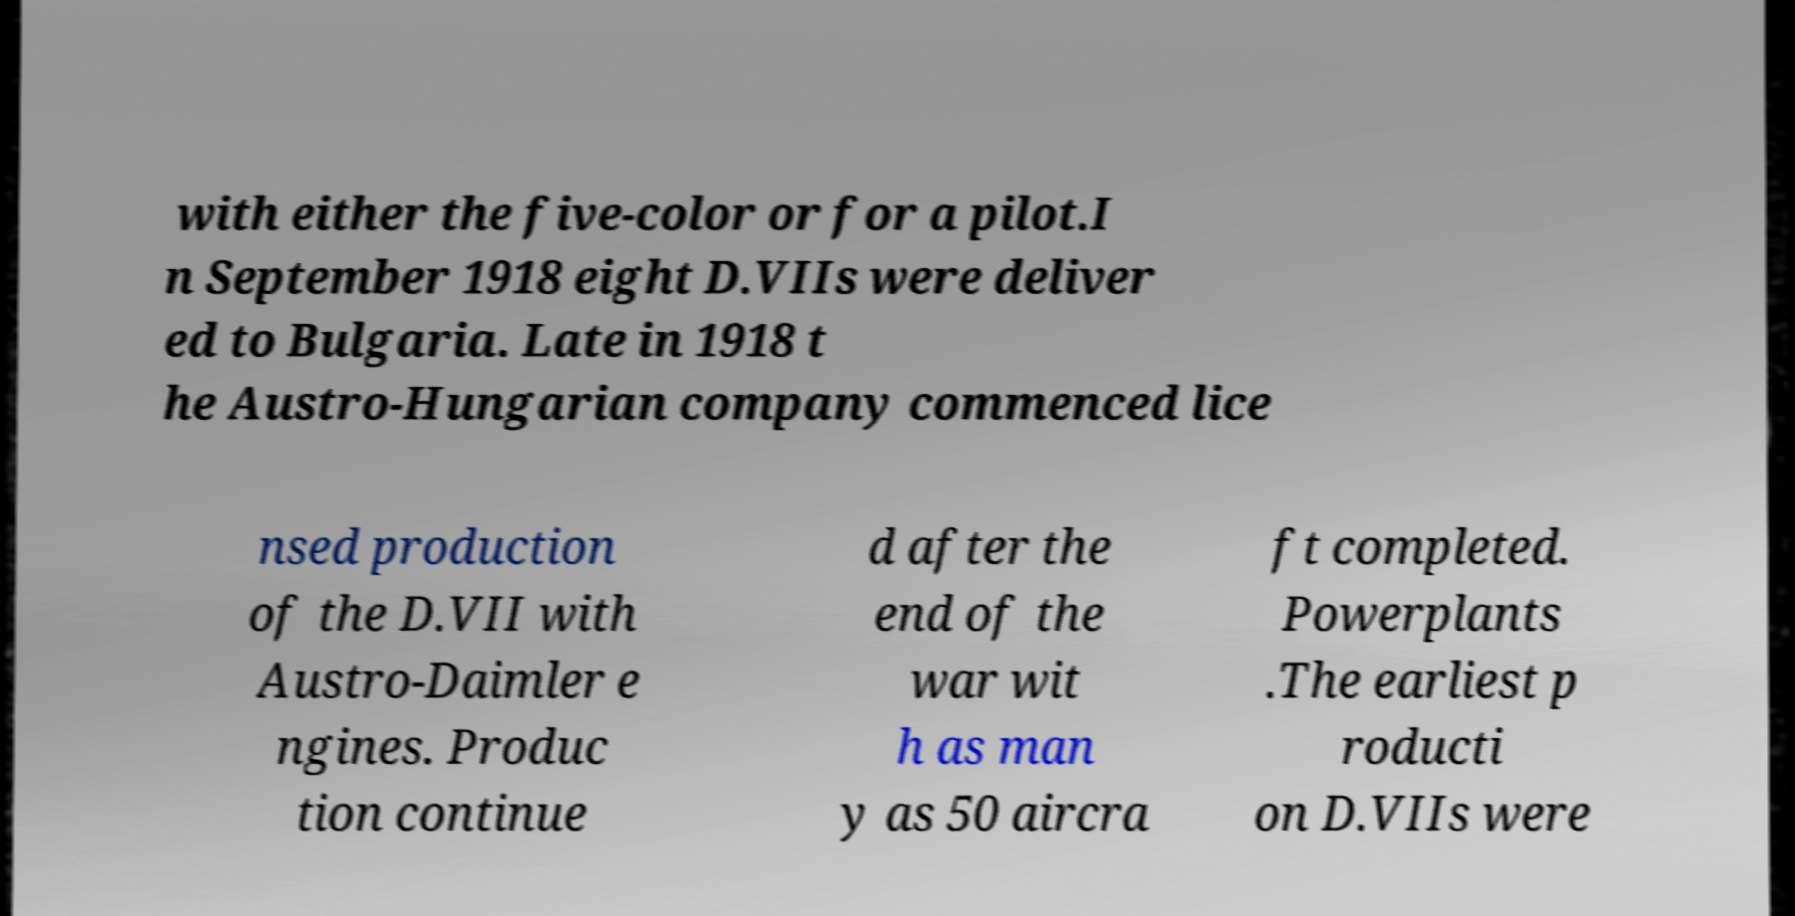What messages or text are displayed in this image? I need them in a readable, typed format. with either the five-color or for a pilot.I n September 1918 eight D.VIIs were deliver ed to Bulgaria. Late in 1918 t he Austro-Hungarian company commenced lice nsed production of the D.VII with Austro-Daimler e ngines. Produc tion continue d after the end of the war wit h as man y as 50 aircra ft completed. Powerplants .The earliest p roducti on D.VIIs were 